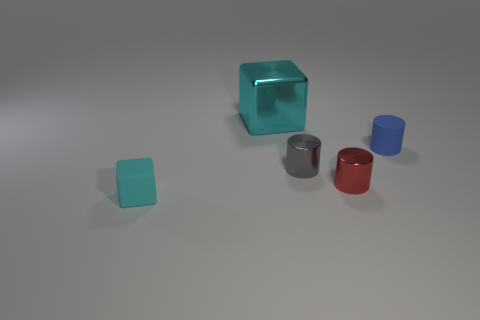Add 3 blue matte cylinders. How many objects exist? 8 Subtract all cubes. How many objects are left? 3 Add 4 tiny purple rubber spheres. How many tiny purple rubber spheres exist? 4 Subtract 0 brown cubes. How many objects are left? 5 Subtract all small cyan rubber cubes. Subtract all big cyan metallic objects. How many objects are left? 3 Add 4 metal cylinders. How many metal cylinders are left? 6 